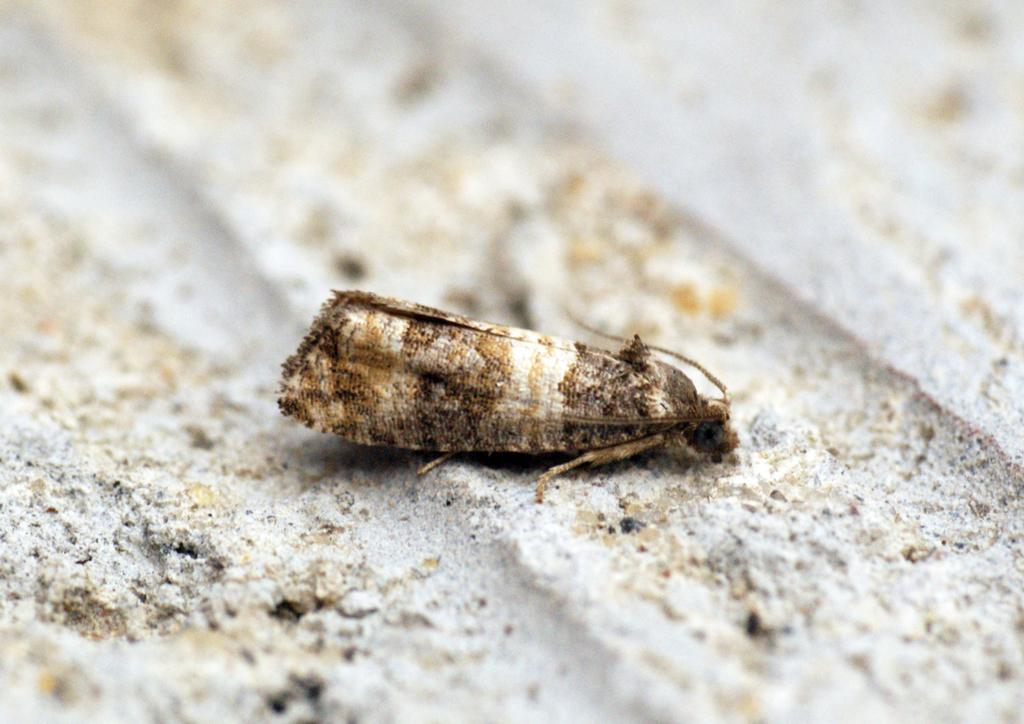What type of creature can be seen in the image? There is an insect in the image. Where is the insect located in the image? The insect is on the ground. How does the insect provide comfort to the person in the image? There is no person present in the image, and the insect is not providing comfort. 